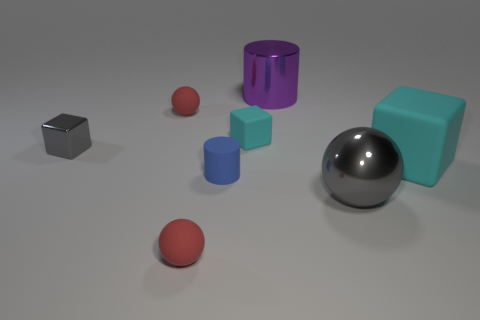What might be the purpose of arranging these objects like this? The arrangement of these objects could serve multiple purposes. It might be an artistic composition, exploring balance and color contrasts between the various geometric shapes and surfaces. Alternatively, it could be an educational setup designed to teach concepts of geometry, color theory, or even photography lighting, given the different shadows and highlights. The simplicity and clarity of the setup suggest that it's intended for visual demonstration or aesthetic purposes. 